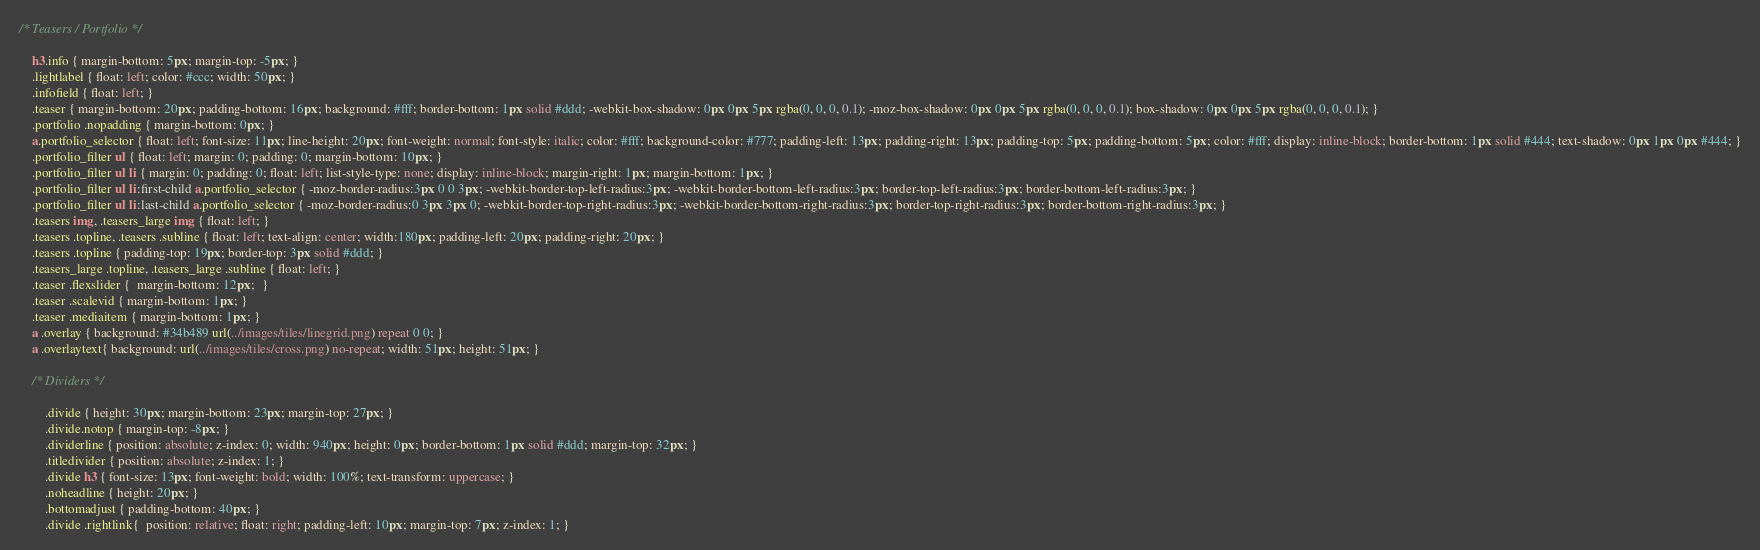Convert code to text. <code><loc_0><loc_0><loc_500><loc_500><_CSS_>/* Teasers / Portfolio */

    h3.info { margin-bottom: 5px; margin-top: -5px; }
    .lightlabel { float: left; color: #ccc; width: 50px; }
    .infofield { float: left; }
    .teaser { margin-bottom: 20px; padding-bottom: 16px; background: #fff; border-bottom: 1px solid #ddd; -webkit-box-shadow: 0px 0px 5px rgba(0, 0, 0, 0.1); -moz-box-shadow: 0px 0px 5px rgba(0, 0, 0, 0.1); box-shadow: 0px 0px 5px rgba(0, 0, 0, 0.1); }
    .portfolio .nopadding { margin-bottom: 0px; }
    a.portfolio_selector { float: left; font-size: 11px; line-height: 20px; font-weight: normal; font-style: italic; color: #fff; background-color: #777; padding-left: 13px; padding-right: 13px; padding-top: 5px; padding-bottom: 5px; color: #fff; display: inline-block; border-bottom: 1px solid #444; text-shadow: 0px 1px 0px #444; }
    .portfolio_filter ul { float: left; margin: 0; padding: 0; margin-bottom: 10px; }
    .portfolio_filter ul li { margin: 0; padding: 0; float: left; list-style-type: none; display: inline-block; margin-right: 1px; margin-bottom: 1px; }
    .portfolio_filter ul li:first-child a.portfolio_selector { -moz-border-radius:3px 0 0 3px; -webkit-border-top-left-radius:3px; -webkit-border-bottom-left-radius:3px; border-top-left-radius:3px; border-bottom-left-radius:3px; }
    .portfolio_filter ul li:last-child a.portfolio_selector { -moz-border-radius:0 3px 3px 0; -webkit-border-top-right-radius:3px; -webkit-border-bottom-right-radius:3px; border-top-right-radius:3px; border-bottom-right-radius:3px; }
    .teasers img, .teasers_large img { float: left; }
    .teasers .topline, .teasers .subline { float: left; text-align: center; width:180px; padding-left: 20px; padding-right: 20px; }
    .teasers .topline { padding-top: 19px; border-top: 3px solid #ddd; }
    .teasers_large .topline, .teasers_large .subline { float: left; }
    .teaser .flexslider {  margin-bottom: 12px;  }
    .teaser .scalevid { margin-bottom: 1px; }
    .teaser .mediaitem { margin-bottom: 1px; }
    a .overlay { background: #34b489 url(../images/tiles/linegrid.png) repeat 0 0; }
    a .overlaytext{ background: url(../images/tiles/cross.png) no-repeat; width: 51px; height: 51px; }

    /* Dividers */

        .divide { height: 30px; margin-bottom: 23px; margin-top: 27px; }
        .divide.notop { margin-top: -8px; }
        .dividerline { position: absolute; z-index: 0; width: 940px; height: 0px; border-bottom: 1px solid #ddd; margin-top: 32px; }
        .titledivider { position: absolute; z-index: 1; }
        .divide h3 { font-size: 13px; font-weight: bold; width: 100%; text-transform: uppercase; }
        .noheadline { height: 20px; }
        .bottomadjust { padding-bottom: 40px; }
        .divide .rightlink{  position: relative; float: right; padding-left: 10px; margin-top: 7px; z-index: 1; }</code> 